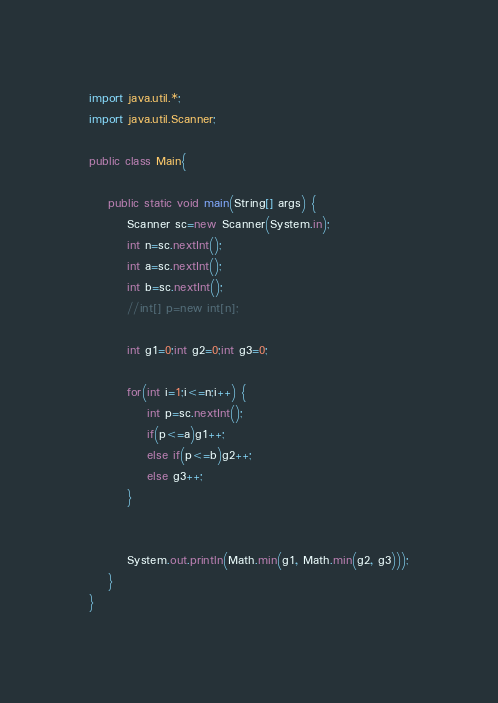<code> <loc_0><loc_0><loc_500><loc_500><_Java_>import java.util.*;
import java.util.Scanner;

public class Main{
	
	public static void main(String[] args) {
		Scanner sc=new Scanner(System.in);
		int n=sc.nextInt();
		int a=sc.nextInt();
		int b=sc.nextInt();
		//int[] p=new int[n];
		
		int g1=0;int g2=0;int g3=0;
		
		for(int i=1;i<=n;i++) {
			int p=sc.nextInt();
			if(p<=a)g1++;
			else if(p<=b)g2++;
			else g3++;
		}
		
		
	    System.out.println(Math.min(g1, Math.min(g2, g3)));
	}
}
</code> 